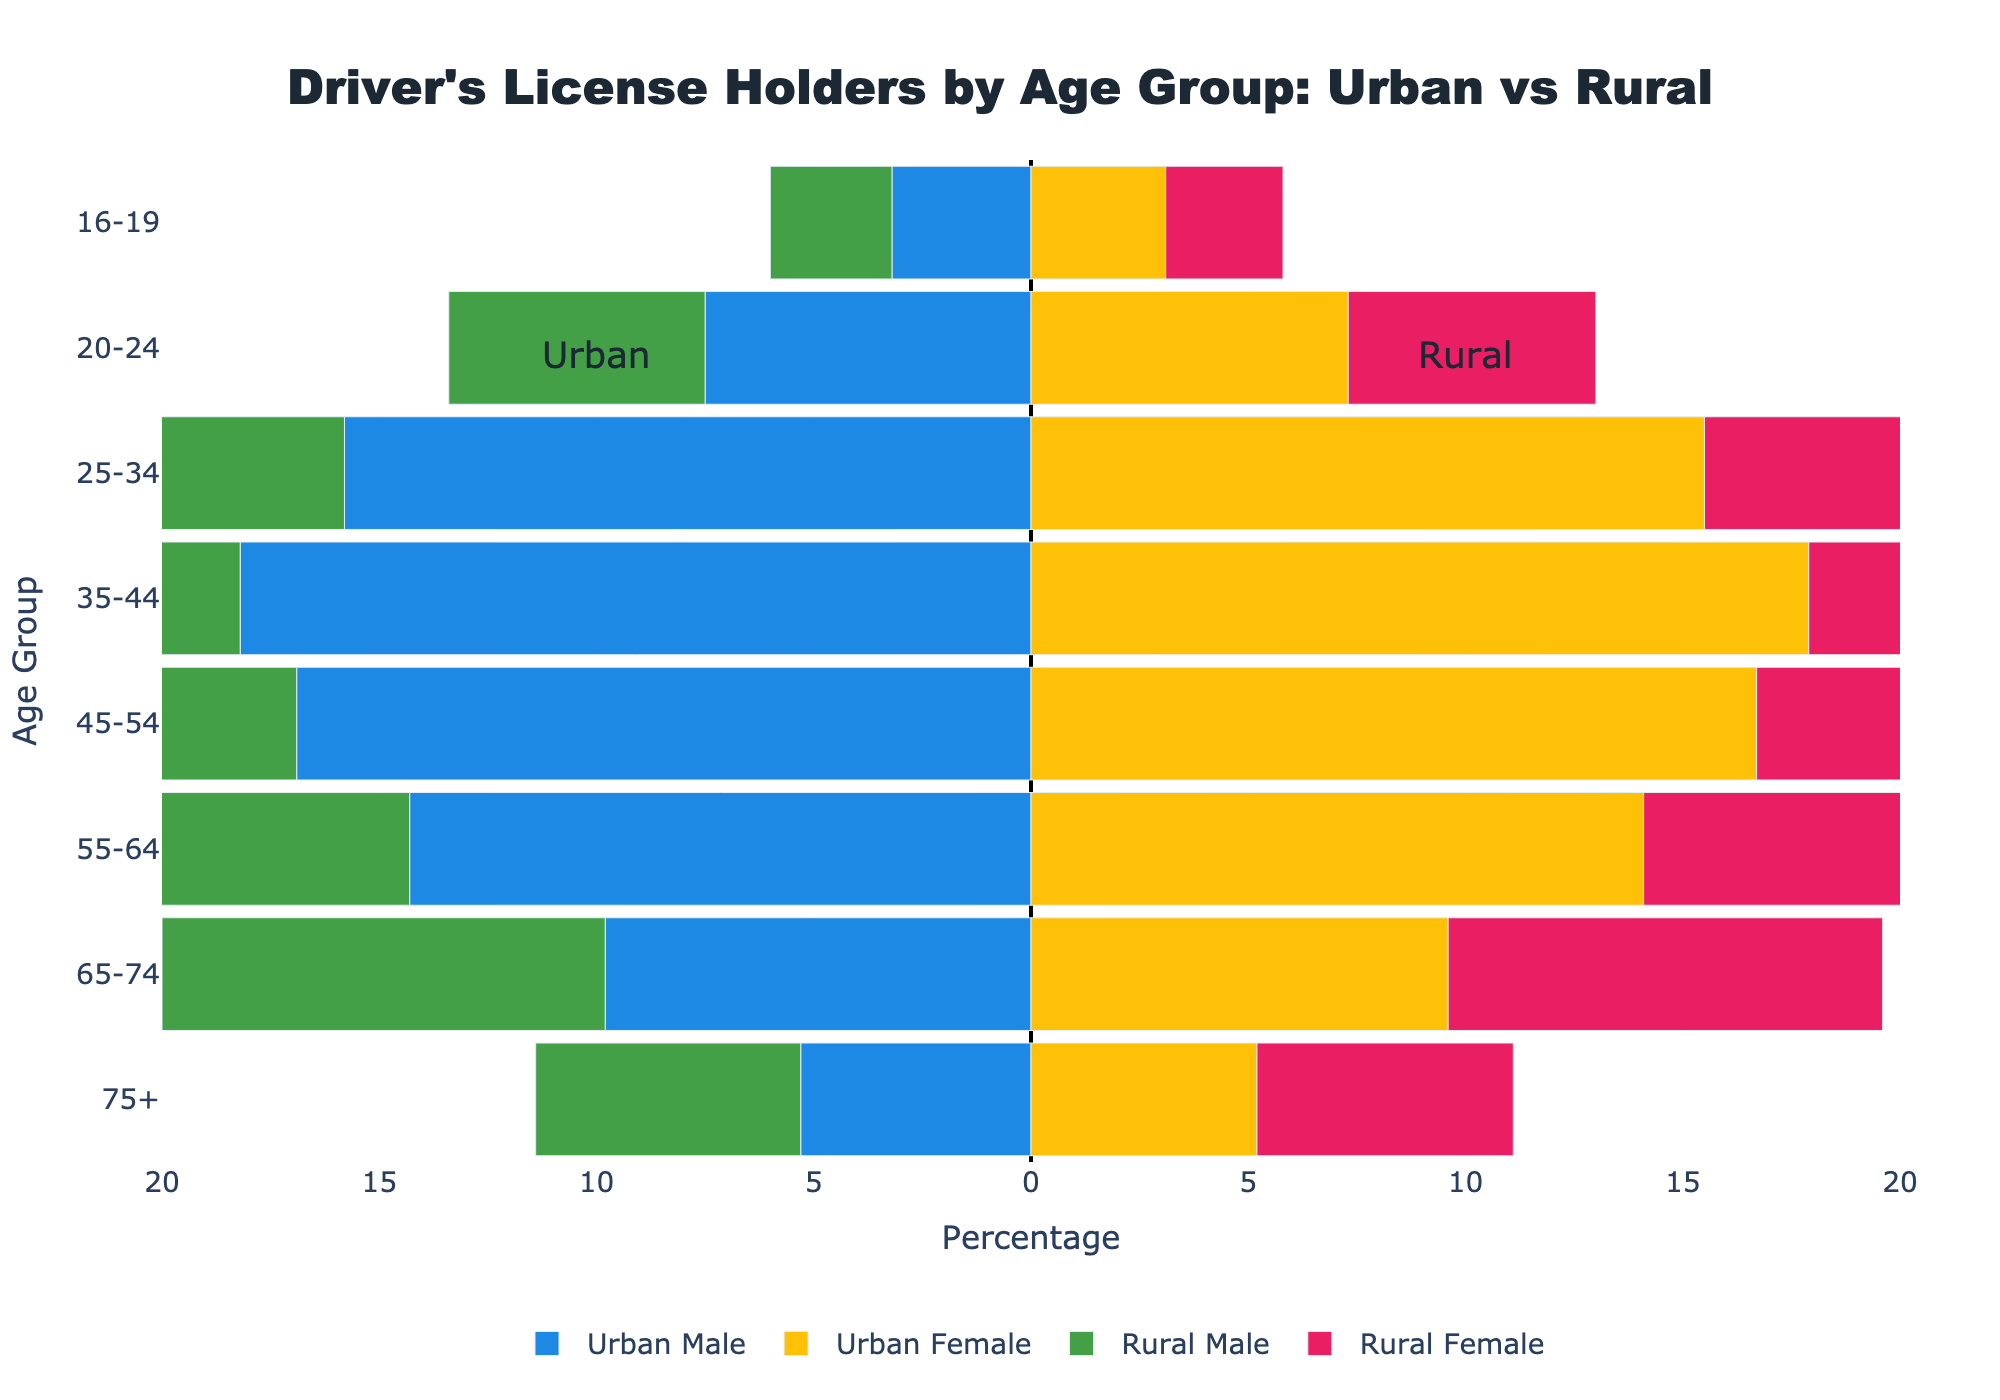What does the title of the figure indicate? The title of the figure is "Driver's License Holders by Age Group: Urban vs Rural," which indicates that the plot is comparing the percentage of driver's license holders across different age groups in urban and rural areas.
Answer: It indicates a comparison of driver's license holders by age group in urban vs. rural areas What is the percentage of urban males holding driver's licenses in the age group 20-24? The data shows that urban males in the age group 20-24 hold 7.5% of driver's licenses.
Answer: 7.5% How do the percentages of rural females with driver's licenses in the age groups 55-64 and 65-74 compare? The data shows that rural females in the age group 55-64 hold 13.5% of driver's licenses, whereas those in the age group 65-74 hold 10.0%.
Answer: 13.5% vs. 10.0% Which group has the highest percentage of driver's license holders among rural males, and what is this percentage? By examining the data for rural males, the age group 35-44 has the highest percentage at 14.8%.
Answer: 35-44 age group, 14.8% What is the combined percentage of urban females holding driver's licenses in the age groups 25-34 and 35-44? The percentage for urban females in the age group 25-34 is 15.5%, and for the age group 35-44, it is 17.9%. Combining these percentages: 15.5 + 17.9 = 33.4%.
Answer: 33.4% In which age group is the difference in the percentage of driver's license holders between rural females and urban females the greatest? For the age group 20-24, urban females hold 7.3% of driver's licenses while rural females hold 5.7%. The difference is 7.3 - 5.7 = 1.6%. Whereas in other age groups, the differences are either smaller or equal, with the largest difference being in this age group.
Answer: 20-24 age group What can you infer about the driver's license holding trends for people aged 75+ in urban vs. rural areas? For the age group 75+, urban males hold 5.3%, urban females hold 5.2%, rural males hold 6.1%, and rural females hold 5.9%. We can infer that a higher percentage of people aged 75+ in rural areas hold driver's licenses compared to their urban counterparts.
Answer: Higher in rural areas How does the percentage of rural males with driver's licenses in the 16-19 age group compare to urban males in the same age group? The data indicates that rural males in the 16-19 age group hold 2.8%, while urban males hold 3.2% of driver's licenses.
Answer: Urban males have a higher percentage Is there any age group where urban females show a lower percentage of driver's licenses compared to rural females? Yes, in the age group 65-74, urban females have a percentage of 9.6%, while rural females have a percentage of 10.0%.
Answer: 65-74 age group Which age group shows the smallest difference in driver's license holders between urban and rural males, and what is that difference? In the age group 55-64, urban males hold 14.3%, and rural males hold 13.7%. The difference is 14.3 - 13.7 = 0.6%, which is the smallest difference among the age groups.
Answer: 55-64 age group, 0.6% 